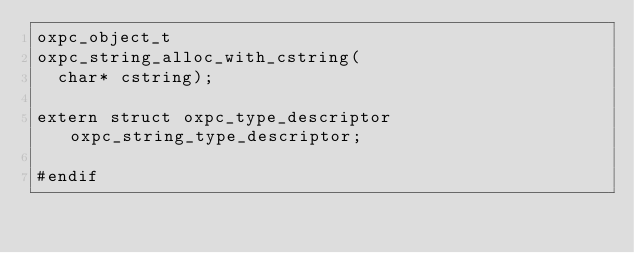Convert code to text. <code><loc_0><loc_0><loc_500><loc_500><_C_>oxpc_object_t
oxpc_string_alloc_with_cstring(
  char* cstring);

extern struct oxpc_type_descriptor oxpc_string_type_descriptor;

#endif
</code> 